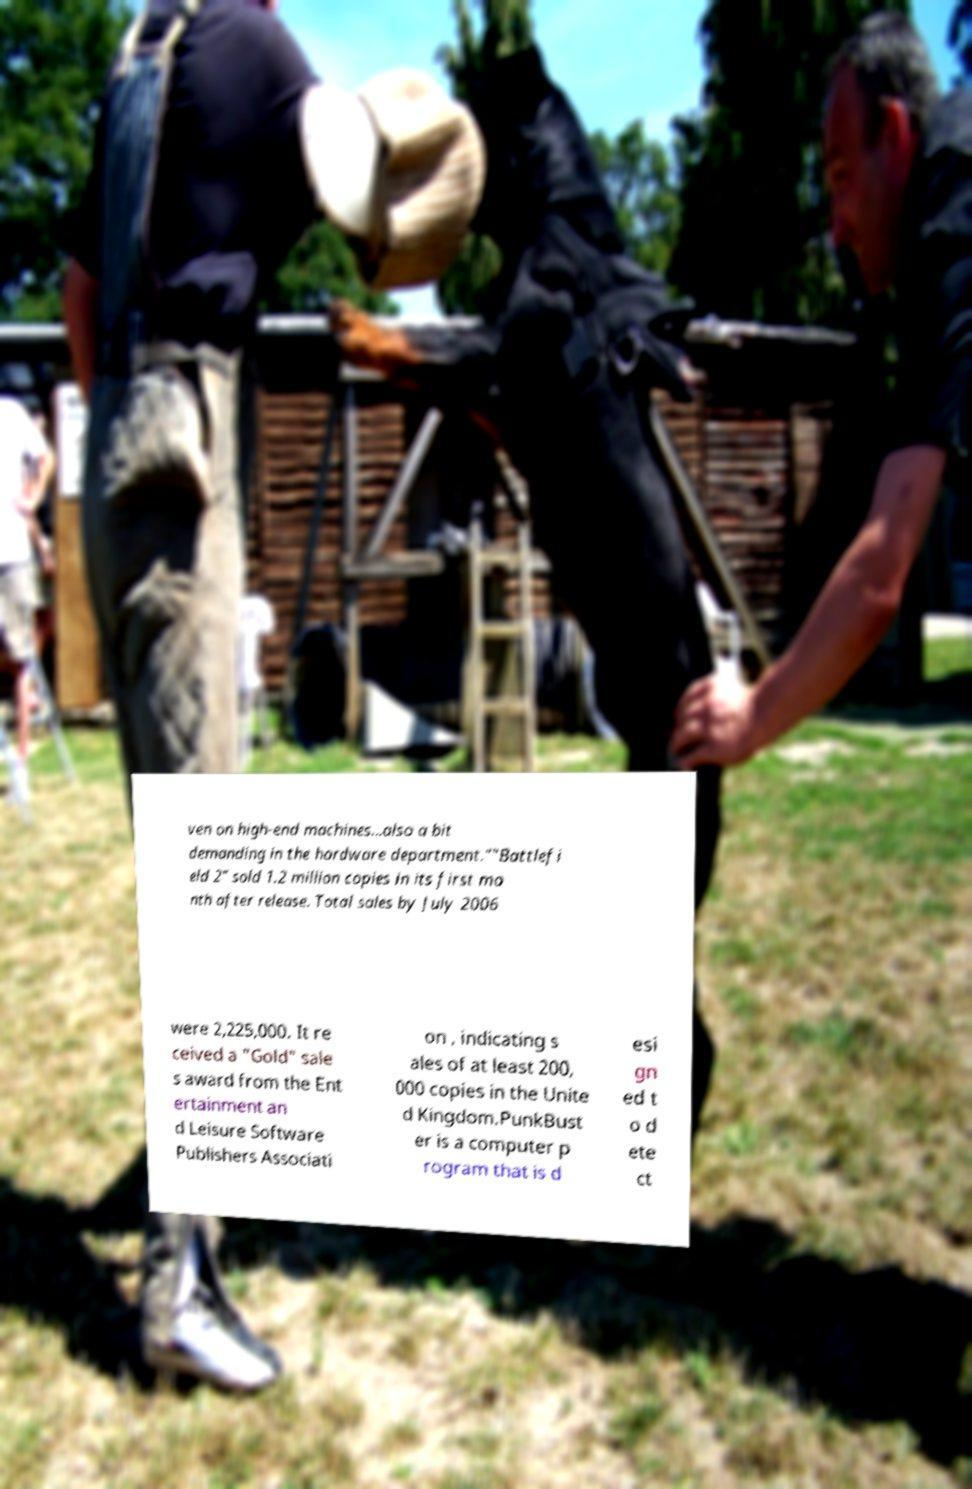Can you accurately transcribe the text from the provided image for me? ven on high-end machines...also a bit demanding in the hardware department.""Battlefi eld 2" sold 1.2 million copies in its first mo nth after release. Total sales by July 2006 were 2,225,000. It re ceived a "Gold" sale s award from the Ent ertainment an d Leisure Software Publishers Associati on , indicating s ales of at least 200, 000 copies in the Unite d Kingdom.PunkBust er is a computer p rogram that is d esi gn ed t o d ete ct 